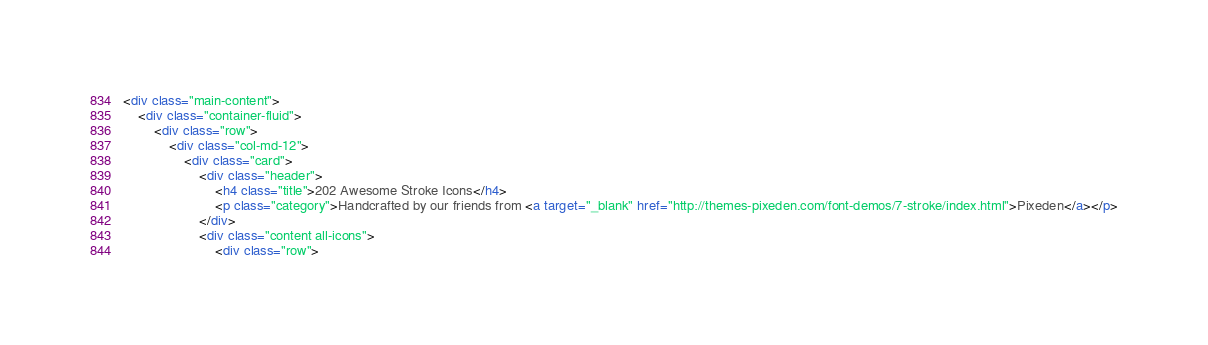<code> <loc_0><loc_0><loc_500><loc_500><_HTML_><div class="main-content">
    <div class="container-fluid">
        <div class="row">
            <div class="col-md-12">
                <div class="card">
                    <div class="header">
                        <h4 class="title">202 Awesome Stroke Icons</h4>
                        <p class="category">Handcrafted by our friends from <a target="_blank" href="http://themes-pixeden.com/font-demos/7-stroke/index.html">Pixeden</a></p>
                    </div>
                    <div class="content all-icons">
                        <div class="row"></code> 